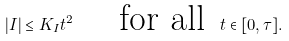<formula> <loc_0><loc_0><loc_500><loc_500>| I | \leq K _ { I } t ^ { 2 } \quad \text { for all } \, t \in [ 0 , \tau ] .</formula> 